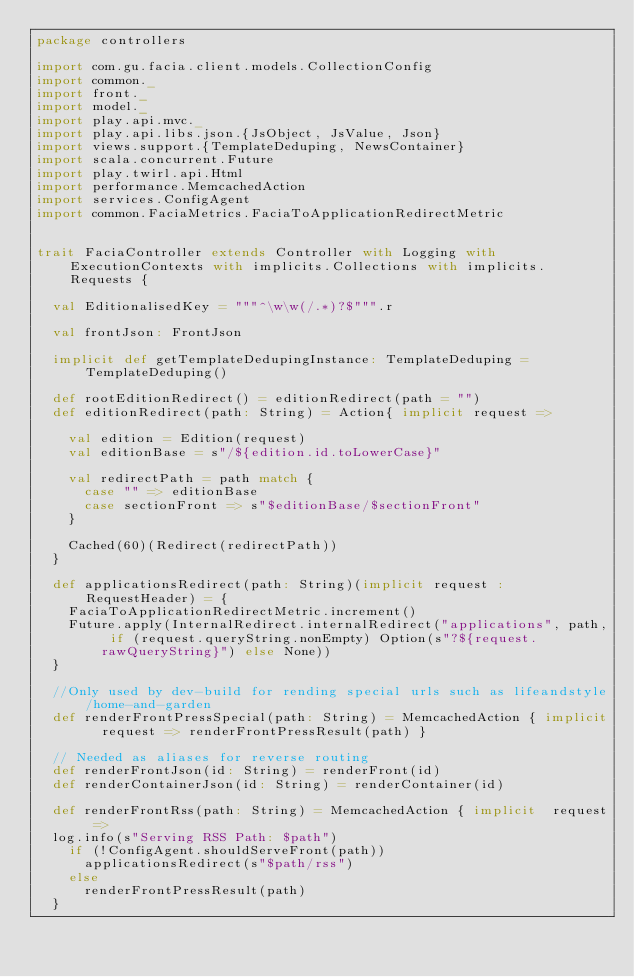Convert code to text. <code><loc_0><loc_0><loc_500><loc_500><_Scala_>package controllers

import com.gu.facia.client.models.CollectionConfig
import common._
import front._
import model._
import play.api.mvc._
import play.api.libs.json.{JsObject, JsValue, Json}
import views.support.{TemplateDeduping, NewsContainer}
import scala.concurrent.Future
import play.twirl.api.Html
import performance.MemcachedAction
import services.ConfigAgent
import common.FaciaMetrics.FaciaToApplicationRedirectMetric


trait FaciaController extends Controller with Logging with ExecutionContexts with implicits.Collections with implicits.Requests {

  val EditionalisedKey = """^\w\w(/.*)?$""".r

  val frontJson: FrontJson

  implicit def getTemplateDedupingInstance: TemplateDeduping = TemplateDeduping()

  def rootEditionRedirect() = editionRedirect(path = "")
  def editionRedirect(path: String) = Action{ implicit request =>

    val edition = Edition(request)
    val editionBase = s"/${edition.id.toLowerCase}"

    val redirectPath = path match {
      case "" => editionBase
      case sectionFront => s"$editionBase/$sectionFront"
    }

    Cached(60)(Redirect(redirectPath))
  }

  def applicationsRedirect(path: String)(implicit request : RequestHeader) = {
    FaciaToApplicationRedirectMetric.increment()
    Future.apply(InternalRedirect.internalRedirect("applications", path, if (request.queryString.nonEmpty) Option(s"?${request.rawQueryString}") else None))
  }

  //Only used by dev-build for rending special urls such as lifeandstyle/home-and-garden
  def renderFrontPressSpecial(path: String) = MemcachedAction { implicit  request => renderFrontPressResult(path) }

  // Needed as aliases for reverse routing
  def renderFrontJson(id: String) = renderFront(id)
  def renderContainerJson(id: String) = renderContainer(id)

  def renderFrontRss(path: String) = MemcachedAction { implicit  request =>
  log.info(s"Serving RSS Path: $path")
    if (!ConfigAgent.shouldServeFront(path))
      applicationsRedirect(s"$path/rss")
    else
      renderFrontPressResult(path)
  }
</code> 